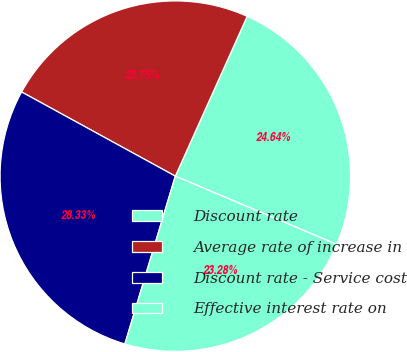Convert chart. <chart><loc_0><loc_0><loc_500><loc_500><pie_chart><fcel>Discount rate<fcel>Average rate of increase in<fcel>Discount rate - Service cost<fcel>Effective interest rate on<nl><fcel>24.64%<fcel>23.75%<fcel>28.33%<fcel>23.28%<nl></chart> 